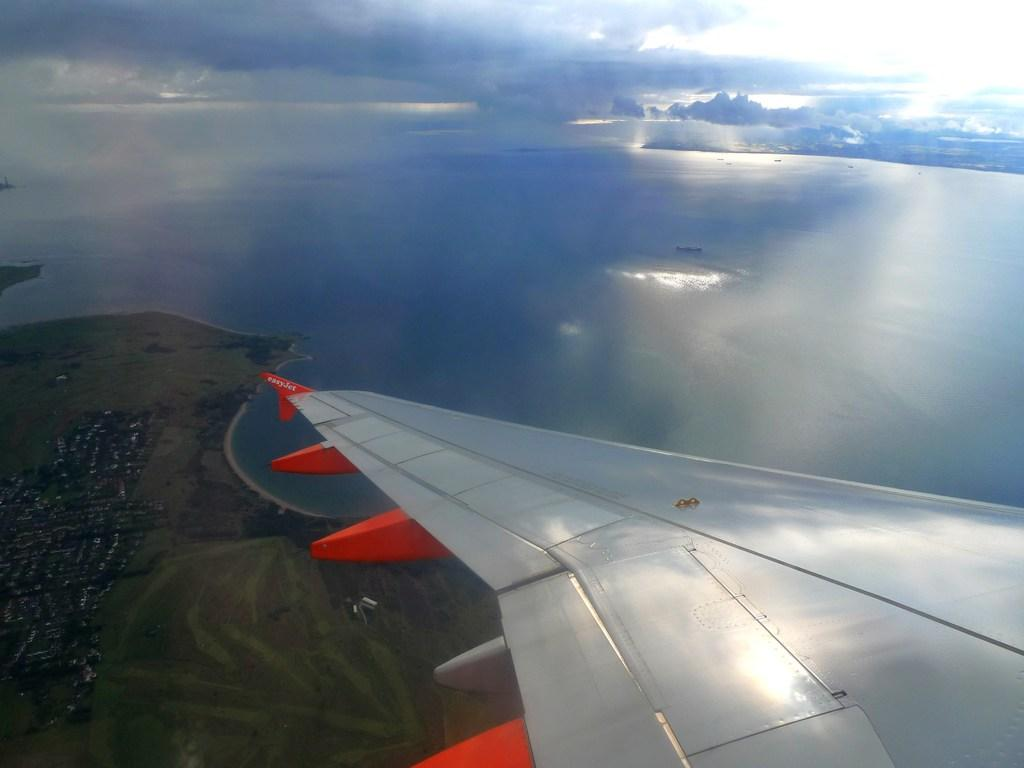What perspective is the image taken from? The image is a top view from the sky. What can be seen in the front of the image? There is a silver color plane wing in the front of the image. What type of water is visible in the image? There is sea water visible in the image. What type of terrain is visible in the image? There is land visible in the image. Where is the scarecrow standing in the image? There is no scarecrow present in the image. What type of sand can be seen on the beach in the image? There is no beach visible in the image, so it is not possible to determine the type of sand. 